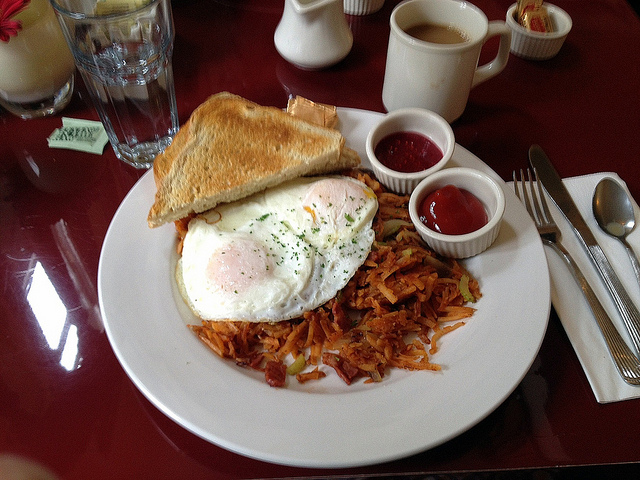What type of breakfast foods are on the white plate? The white plate in the image contains a hearty and traditional breakfast arrangement. It features crispy hash browns, two eggs poached to perfection, and golden-brown toast slices. Accompanying these are two small cups of ketchup, perfect for adding a tangy flavor to the meal. 